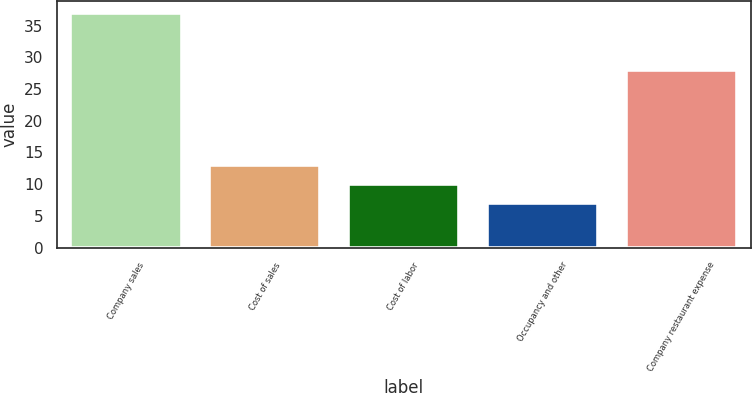Convert chart to OTSL. <chart><loc_0><loc_0><loc_500><loc_500><bar_chart><fcel>Company sales<fcel>Cost of sales<fcel>Cost of labor<fcel>Occupancy and other<fcel>Company restaurant expense<nl><fcel>37<fcel>13<fcel>10<fcel>7<fcel>28<nl></chart> 